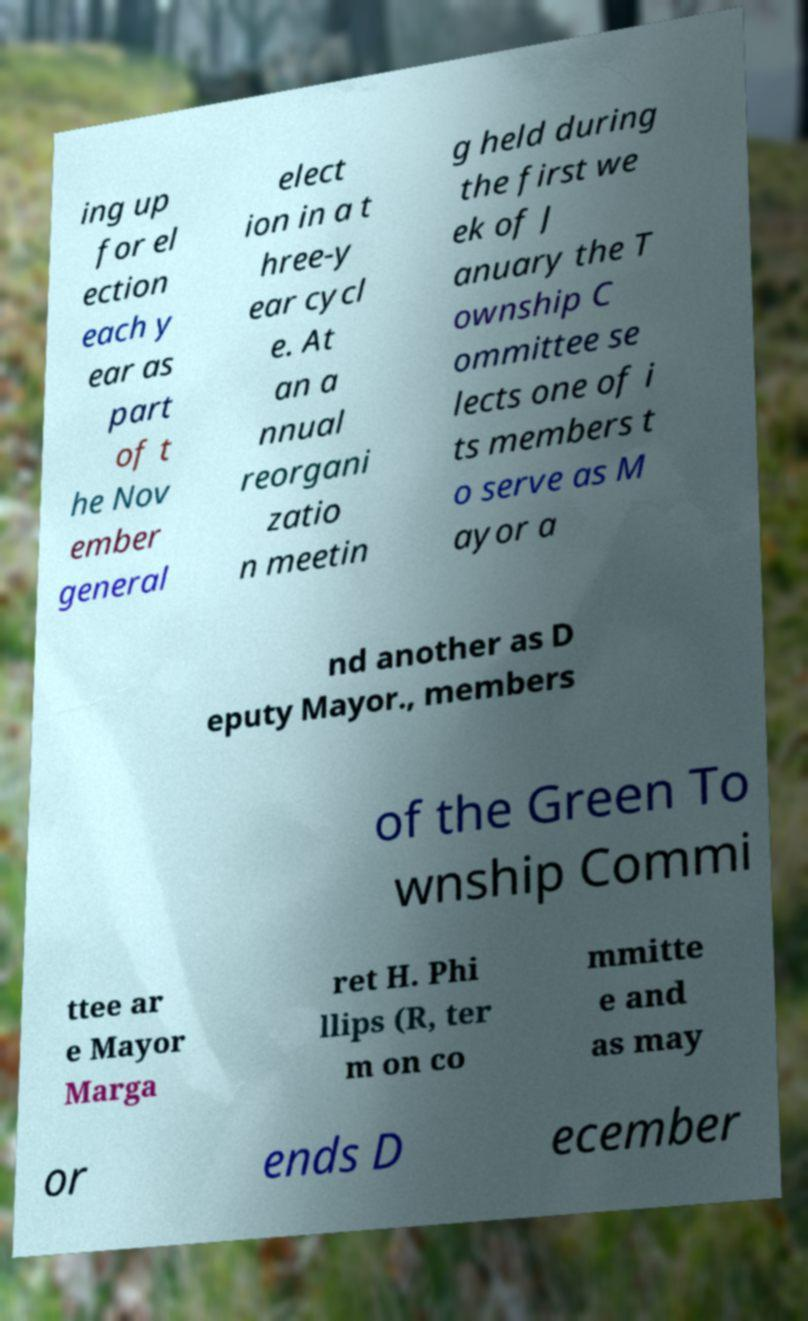Can you accurately transcribe the text from the provided image for me? ing up for el ection each y ear as part of t he Nov ember general elect ion in a t hree-y ear cycl e. At an a nnual reorgani zatio n meetin g held during the first we ek of J anuary the T ownship C ommittee se lects one of i ts members t o serve as M ayor a nd another as D eputy Mayor., members of the Green To wnship Commi ttee ar e Mayor Marga ret H. Phi llips (R, ter m on co mmitte e and as may or ends D ecember 